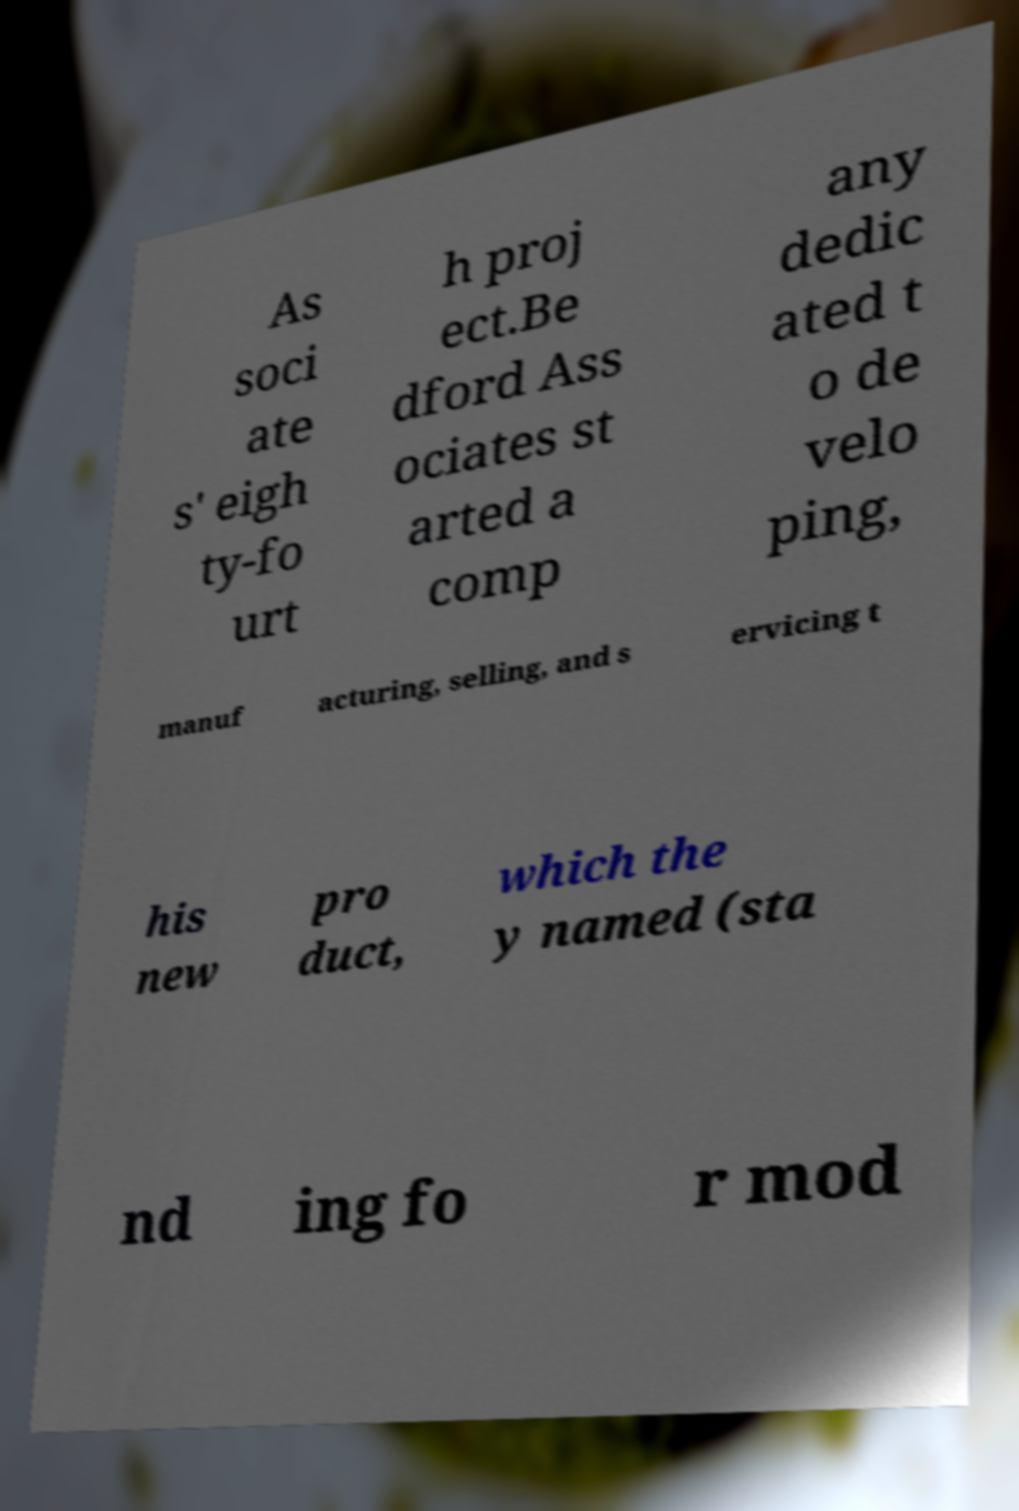Can you read and provide the text displayed in the image?This photo seems to have some interesting text. Can you extract and type it out for me? As soci ate s' eigh ty-fo urt h proj ect.Be dford Ass ociates st arted a comp any dedic ated t o de velo ping, manuf acturing, selling, and s ervicing t his new pro duct, which the y named (sta nd ing fo r mod 